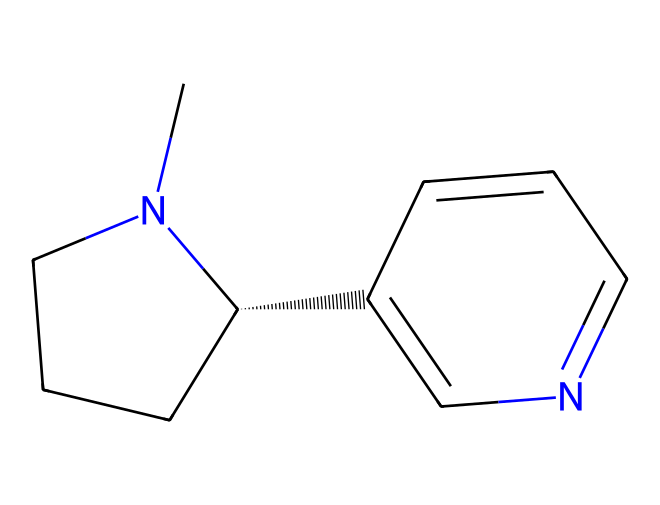What is the molecular formula of nicotine? To determine the molecular formula, we need to count the different atoms from the SMILES representation. The structure indicates there are 10 carbon (C) atoms, 14 hydrogen (H) atoms, and 2 nitrogen (N) atoms. Thus, the molecular formula is C10H14N2.
Answer: C10H14N2 How many nitrogen atoms are present in the structure? By inspecting the SMILES representation, we can identify two nitrogen atoms in the structure of nicotine. The letter "N" appears twice, indicating there are two nitrogen atoms.
Answer: 2 What type of compound is nicotine classified as? Nicotine is classified as an alkaloid due to its basic nature and the presence of nitrogen atoms in its structure, which are characteristics of alkaloids.
Answer: alkaloid How many rings are present in the molecular structure? Looking at the SMILES, we can identify two cyclic structures (rings): the five-membered ring and the six-membered ring. Count the numbers associated with "R" which signify ring closures, showing there are two rings.
Answer: 2 Which atom in the structure is responsible for the basicity of nicotine? The presence of nitrogen atoms, specifically the lone pair on the nitrogen, contributes to the basicity of nicotine. So, the nitrogen is responsible for its basicity.
Answer: nitrogen 